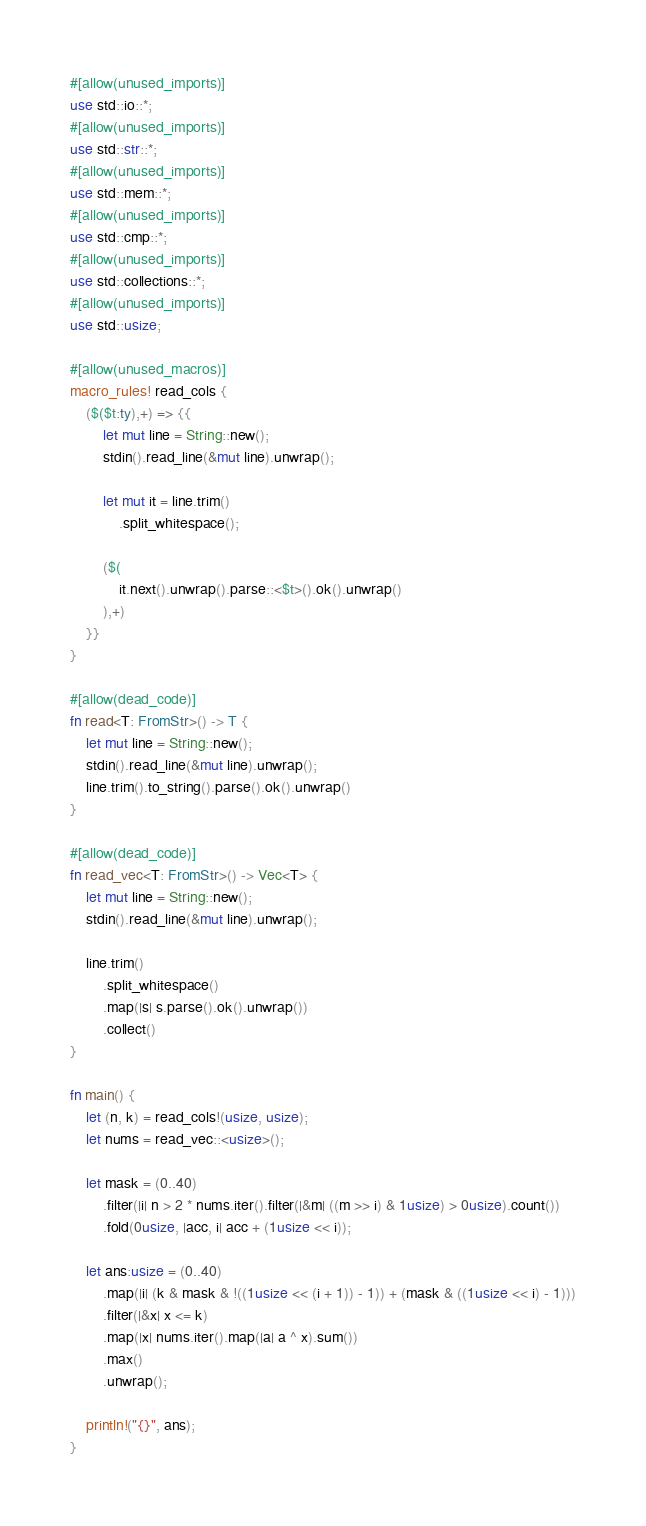<code> <loc_0><loc_0><loc_500><loc_500><_Rust_>#[allow(unused_imports)]
use std::io::*;
#[allow(unused_imports)]
use std::str::*;
#[allow(unused_imports)]
use std::mem::*;
#[allow(unused_imports)]
use std::cmp::*;
#[allow(unused_imports)]
use std::collections::*;
#[allow(unused_imports)]
use std::usize;

#[allow(unused_macros)]
macro_rules! read_cols {
    ($($t:ty),+) => {{
        let mut line = String::new();
        stdin().read_line(&mut line).unwrap();

        let mut it = line.trim()
            .split_whitespace();
        
        ($(
            it.next().unwrap().parse::<$t>().ok().unwrap()
        ),+)
    }}
}

#[allow(dead_code)]
fn read<T: FromStr>() -> T {
    let mut line = String::new();
    stdin().read_line(&mut line).unwrap();
    line.trim().to_string().parse().ok().unwrap()
}

#[allow(dead_code)]
fn read_vec<T: FromStr>() -> Vec<T> {
    let mut line = String::new();
    stdin().read_line(&mut line).unwrap();

    line.trim()
        .split_whitespace()
        .map(|s| s.parse().ok().unwrap())
        .collect()
}

fn main() {
    let (n, k) = read_cols!(usize, usize);
    let nums = read_vec::<usize>();

    let mask = (0..40)
        .filter(|i| n > 2 * nums.iter().filter(|&m| ((m >> i) & 1usize) > 0usize).count())
        .fold(0usize, |acc, i| acc + (1usize << i));
    
    let ans:usize = (0..40)
        .map(|i| (k & mask & !((1usize << (i + 1)) - 1)) + (mask & ((1usize << i) - 1)))
        .filter(|&x| x <= k)
        .map(|x| nums.iter().map(|a| a ^ x).sum())
        .max()
        .unwrap();
    
    println!("{}", ans);
}</code> 